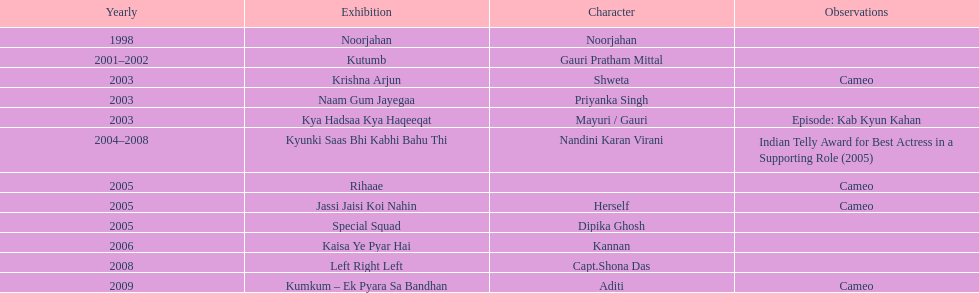The shows with at most 1 cameo Krishna Arjun, Rihaae, Jassi Jaisi Koi Nahin, Kumkum - Ek Pyara Sa Bandhan. 